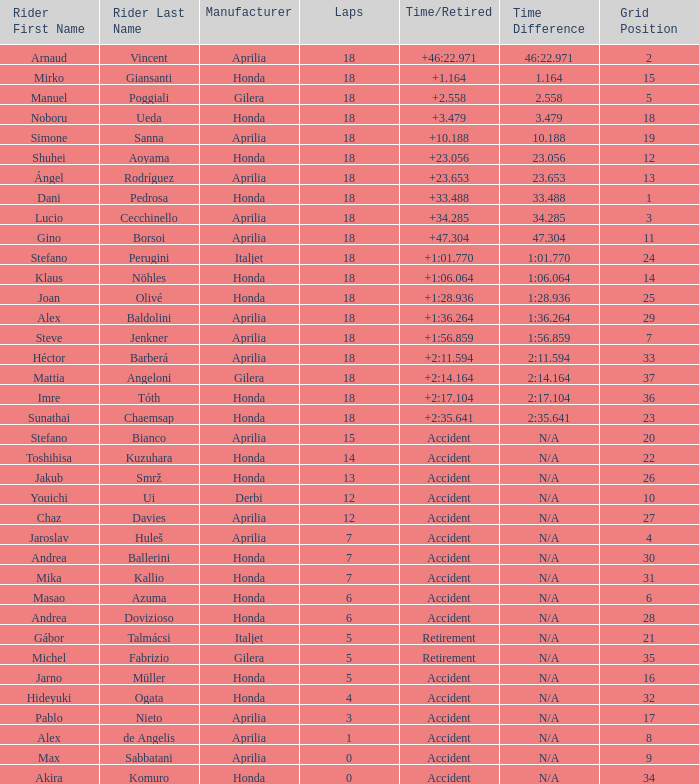Which rider has completed fewer than 15 laps, participated in over 32 grids, and experienced an accident or retirement? Akira Komuro. 